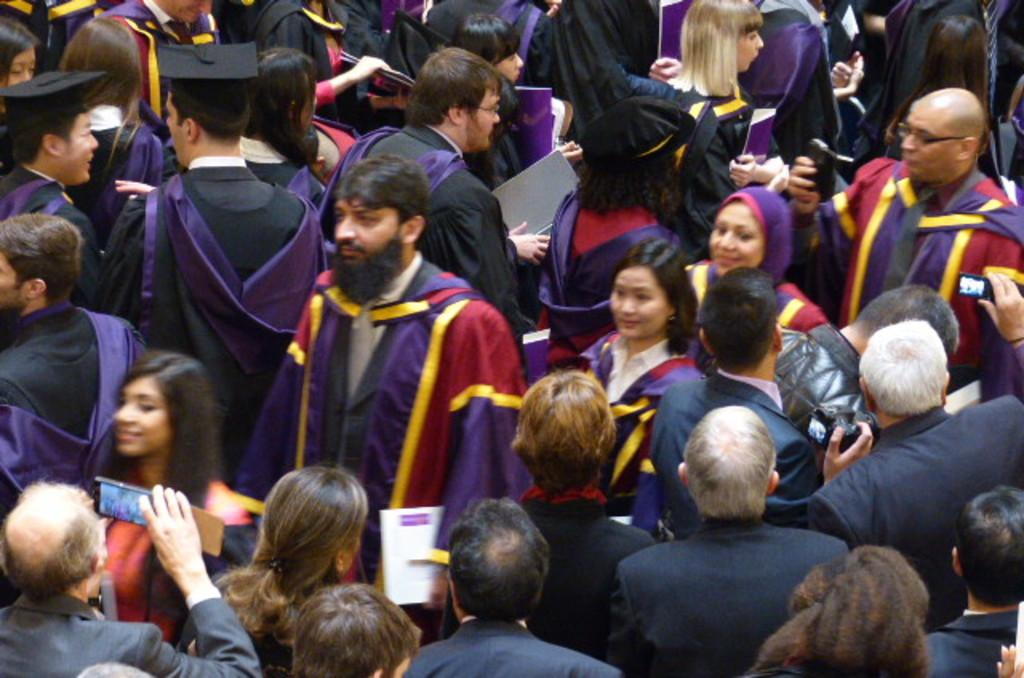What is the main subject of the image? The main subject of the image is a group of people. What are some of the people in the group holding? Some people in the group are holding files and some are holding devices. What type of berry can be seen in the image? There is no berry present in the image; it features a group of people holding files and devices. How many eggs are visible in the image? There are no eggs present in the image. 